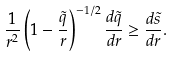Convert formula to latex. <formula><loc_0><loc_0><loc_500><loc_500>\frac { 1 } { r ^ { 2 } } \left ( 1 - \frac { \tilde { q } } { r } \right ) ^ { - 1 / 2 } \frac { d \tilde { q } } { d r } \geq \frac { d \tilde { s } } { d r } .</formula> 